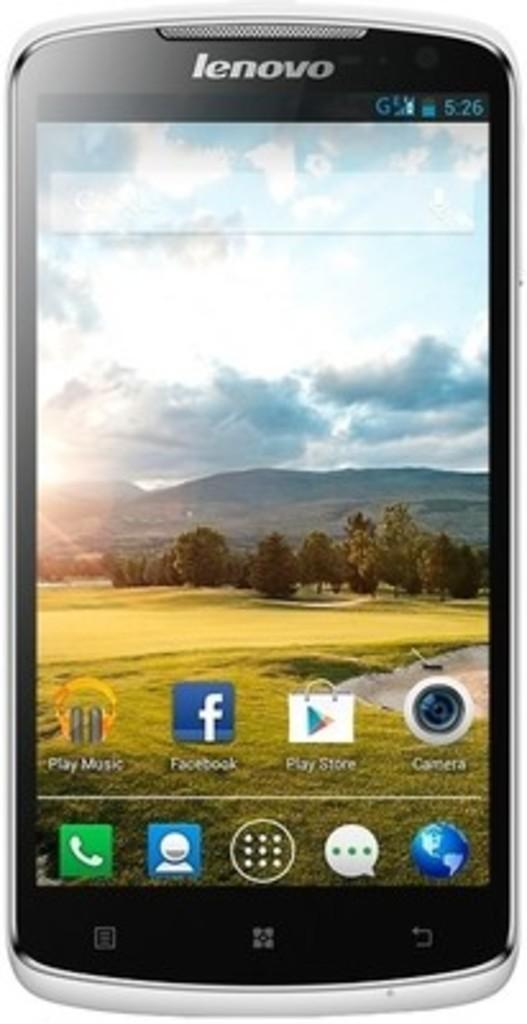Provide a one-sentence caption for the provided image. Lenovo smartphone with apps on its homepage like Facebook, Play music, and Play Store. 